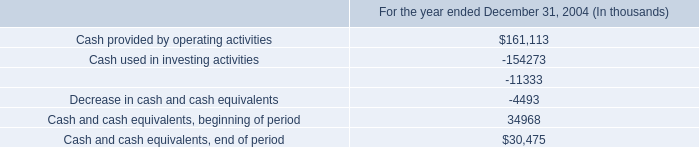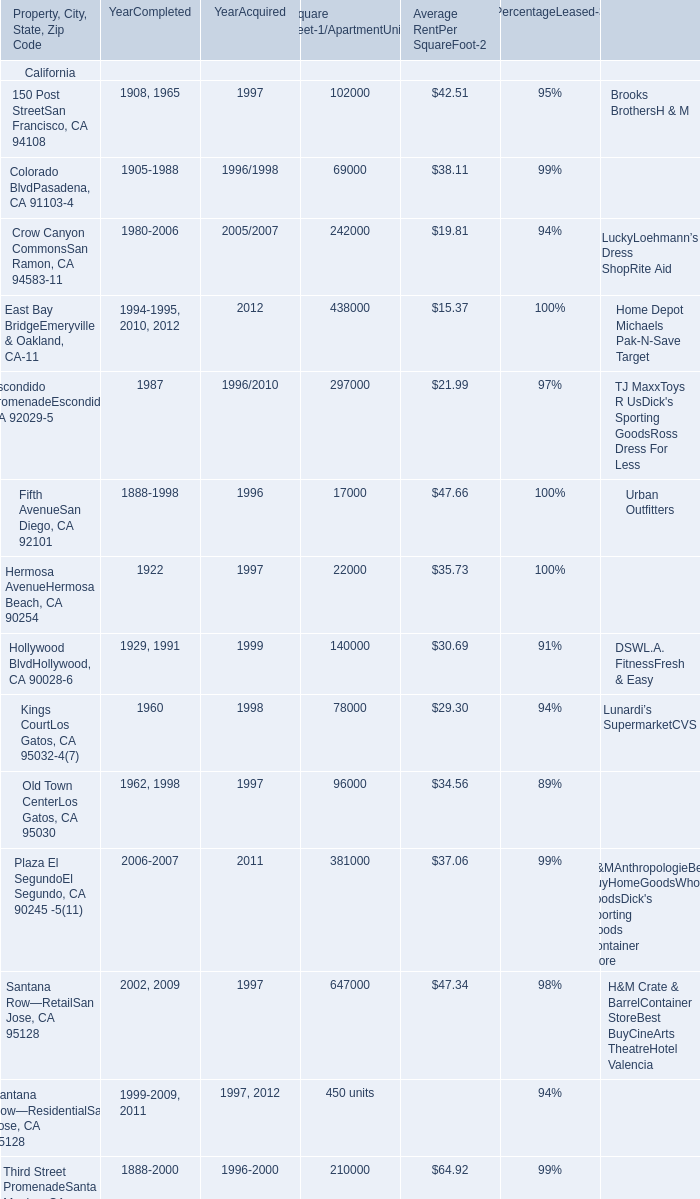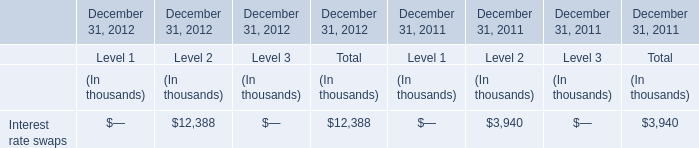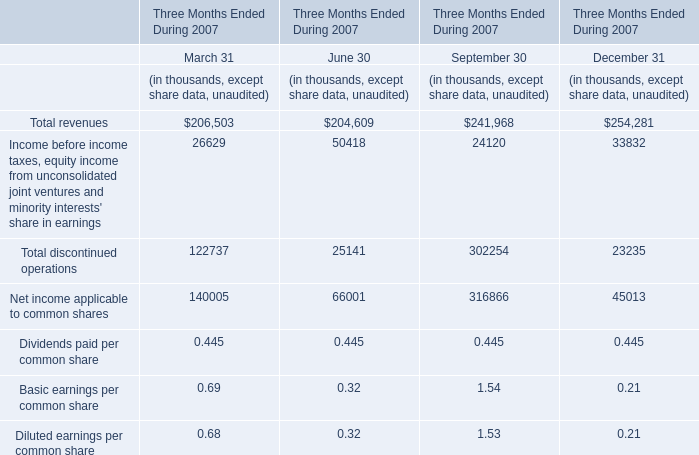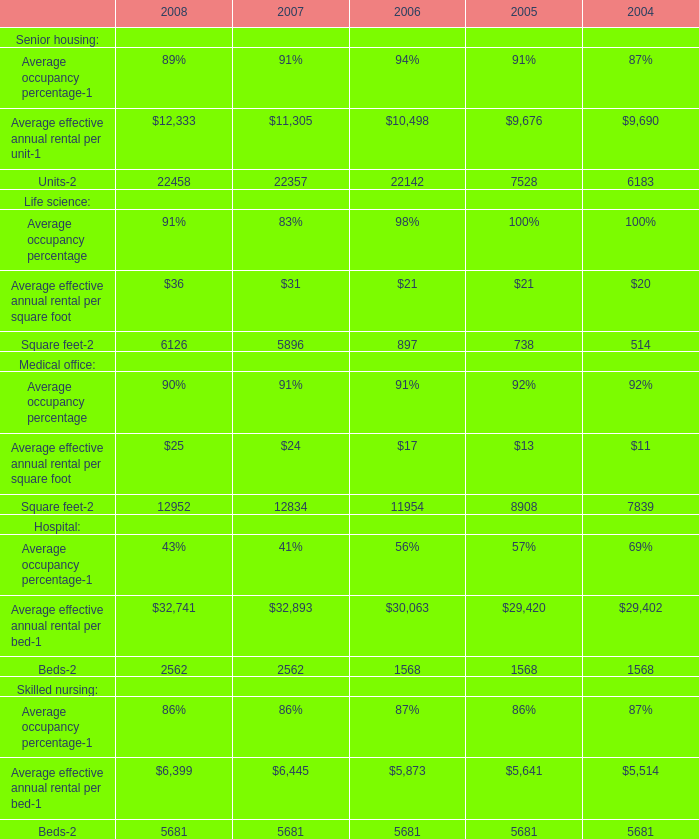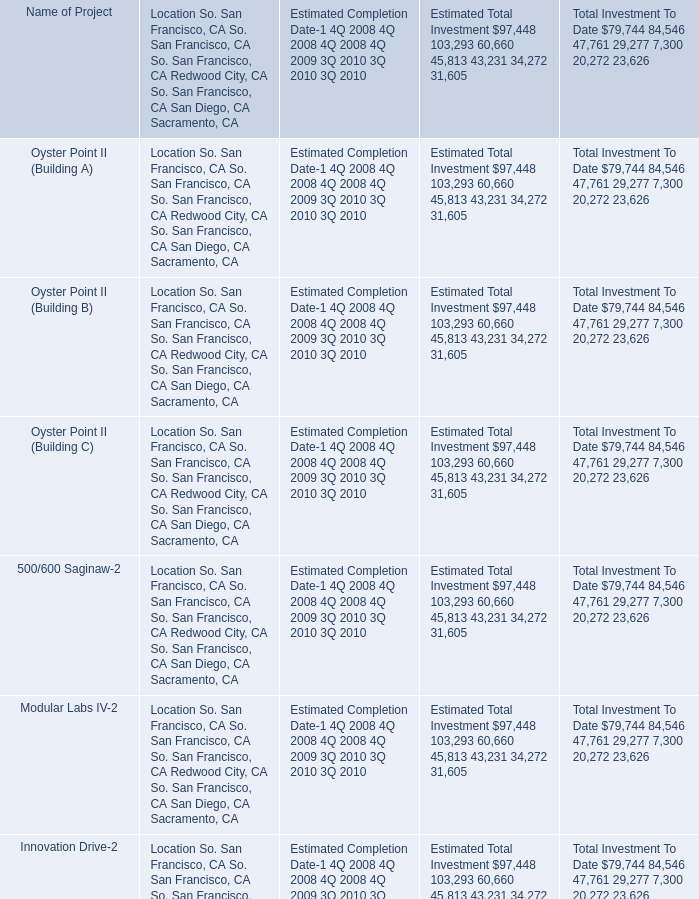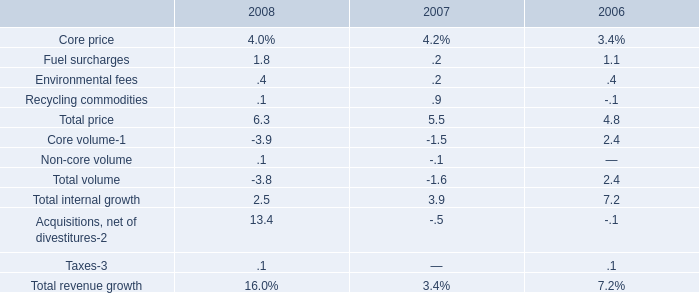In the section with lowest amount of Average RentPer SquareFoot-2, what's the increasing rate of Fifth AvenueSan Diego, CA 92101? 
Computations: ((297000 - 17000) / 17000)
Answer: 16.47059. 